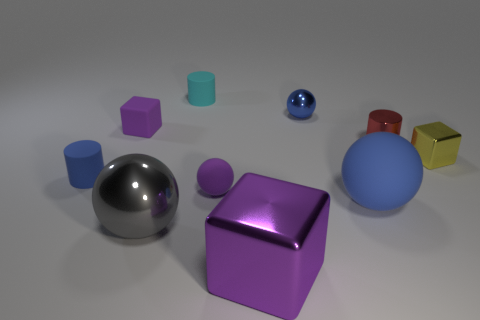Subtract all small yellow cubes. How many cubes are left? 2 Subtract all cyan cylinders. How many cylinders are left? 2 Subtract 3 blocks. How many blocks are left? 0 Subtract all blue spheres. How many yellow cubes are left? 1 Subtract 1 gray spheres. How many objects are left? 9 Subtract all cylinders. How many objects are left? 7 Subtract all green cylinders. Subtract all brown blocks. How many cylinders are left? 3 Subtract all small yellow rubber things. Subtract all purple matte spheres. How many objects are left? 9 Add 4 blue matte spheres. How many blue matte spheres are left? 5 Add 4 blue metallic objects. How many blue metallic objects exist? 5 